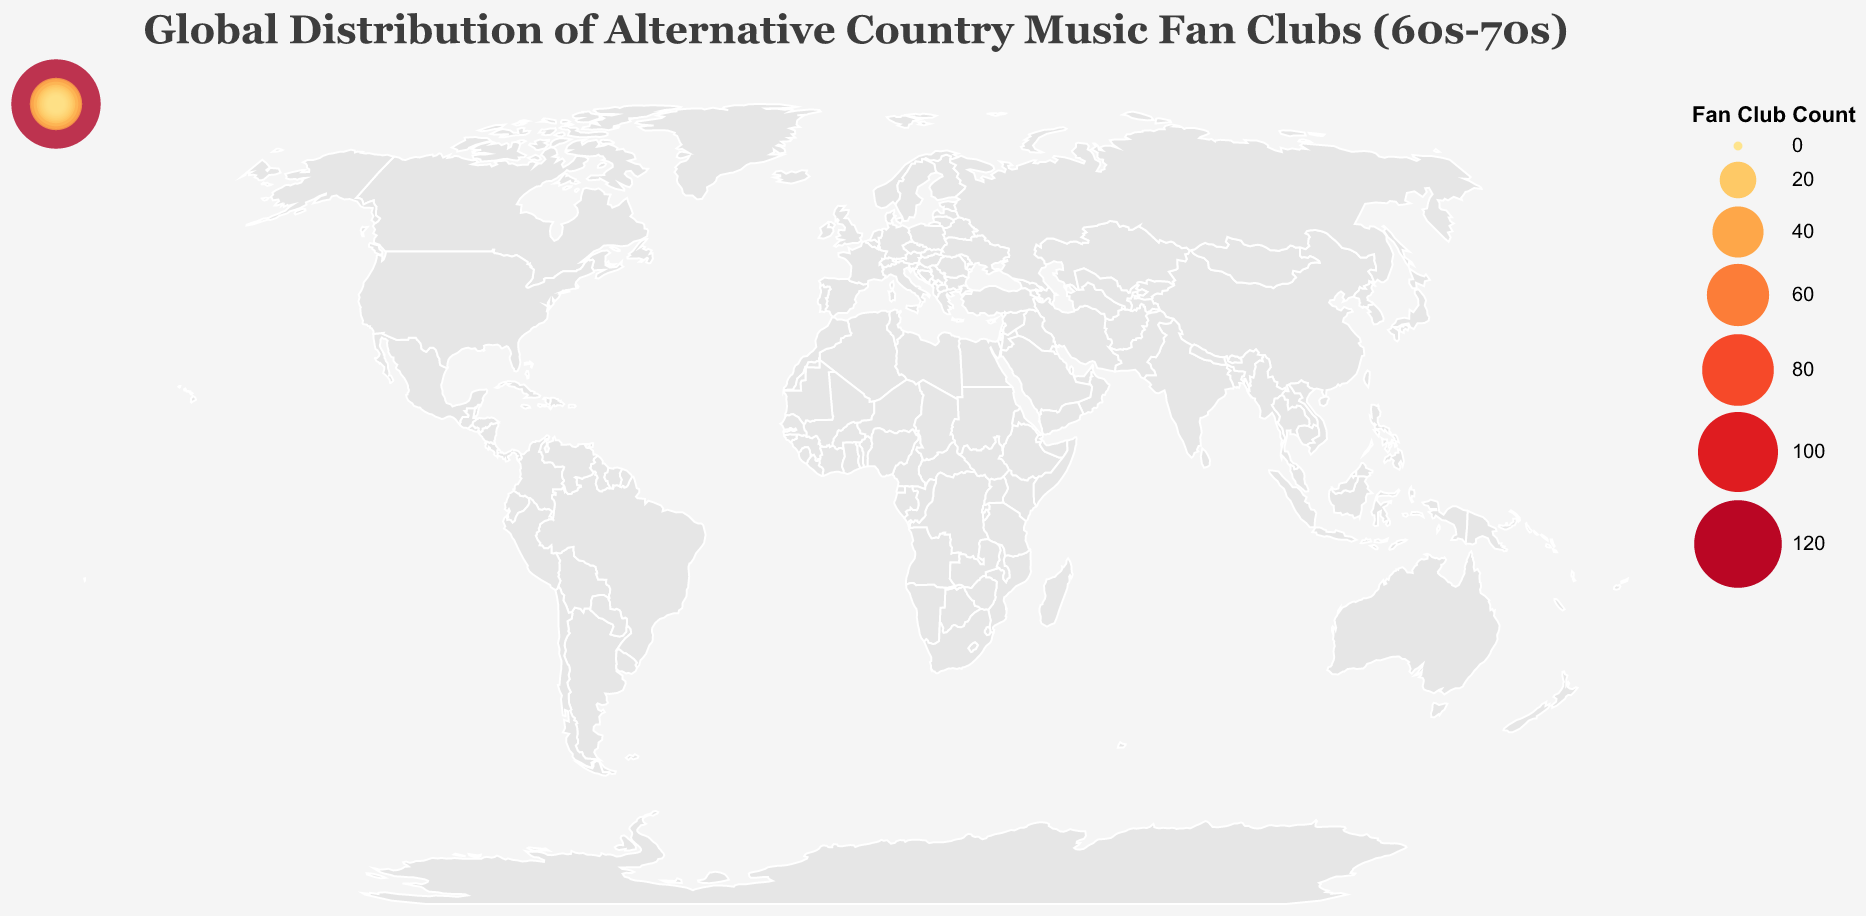How many fan clubs are there in total depicted on the map? To find the total number of fan clubs, sum the fan club counts for all the countries listed in the data. Calculate 125 + 42 + 38 + 30 + 22 + 18 + 15 + 12 + 10 + 8 + 7 + 6 + 5 + 4 + 3, which equals 345.
Answer: 345 Which country has the highest number of alternative country music fan clubs? Identify the country with the largest fan club count in the data. The United States has the highest count with 125 fan clubs.
Answer: United States What is the total number of fan clubs in Europe according to the figure? To find the total number of fan clubs in Europe, sum the fan club counts for European countries: United Kingdom (38), Germany (22), Netherlands (18), Sweden (15), Norway (12), France (8), Ireland (7), Belgium (5), Denmark (4), and Italy (3). Calculate 38 + 22 + 18 + 15 + 12 + 8 + 7 + 5 + 4 + 3, which equals 132.
Answer: 132 How many more fan clubs are there in the United States compared to Canada? Subtract the fan club count of Canada from that of the United States. Calculate 125 - 42, which equals 83.
Answer: 83 Which countries have 10 or fewer fan clubs? Identify the countries from the data with fan club counts of 10 or less. These countries are Japan (10), France (8), Ireland (7), New Zealand (6), Belgium (5), Denmark (4), and Italy (3).
Answer: Japan, France, Ireland, New Zealand, Belgium, Denmark, Italy What percentage of the total fan clubs are located in the United States? Calculate the percentage by dividing the number of fan clubs in the United States (125) by the total number of fan clubs (345) and then multiplying by 100. The calculation is (125 / 345) * 100 ≈ 36.23%.
Answer: 36.23% Which two countries have a combined total of more than 50 fan clubs? Find pairs of countries whose combined fan club counts exceed 50. For example, United States (125) and any other country, or Canada (42) and United Kingdom (38) as 42 + 38 = 80.
Answer: United States and Canada, United Kingdom and Canada What is the average number of fan clubs across all the countries? Find the total number of fan clubs (345) and divide it by the number of countries (15). The calculation is 345 / 15 = 23.
Answer: 23 Which country in Oceania has more fan clubs, Australia or New Zealand? Compare the fan club counts of Australia (30) and New Zealand (6). Australia has more fan clubs.
Answer: Australia What is the median number of fan clubs among the listed countries? Arrange the fan club counts in ascending order: 3, 4, 5, 6, 7, 8, 10, 12, 15, 18, 22, 30, 38, 42, 125. The median is the middle value, which is 12.
Answer: 12 